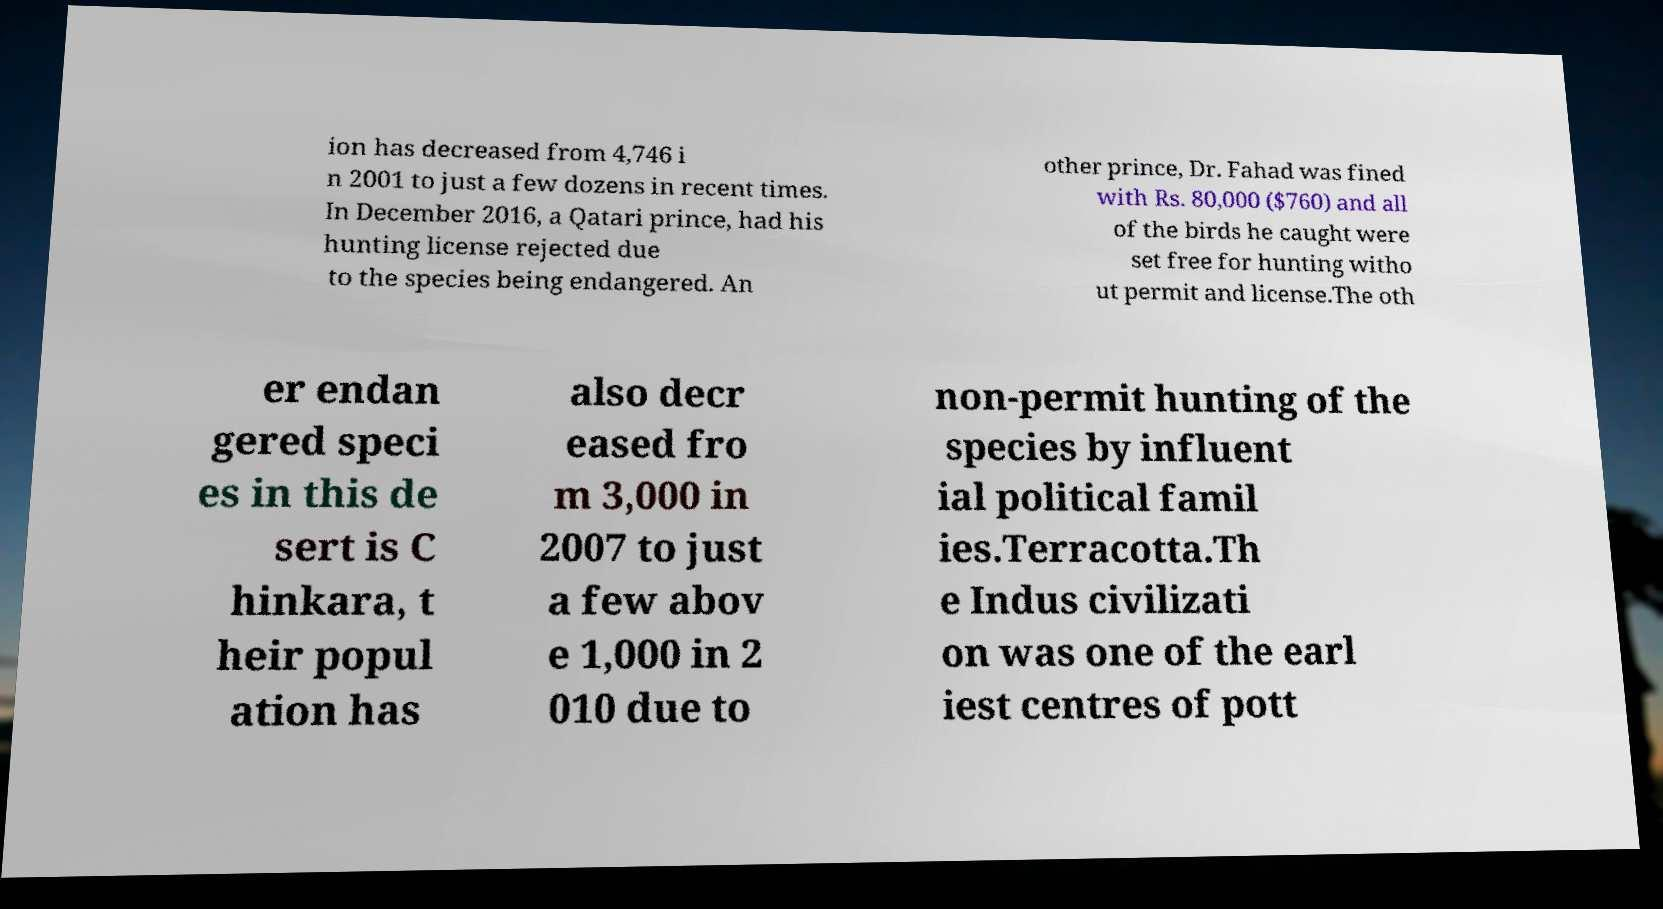I need the written content from this picture converted into text. Can you do that? ion has decreased from 4,746 i n 2001 to just a few dozens in recent times. In December 2016, a Qatari prince, had his hunting license rejected due to the species being endangered. An other prince, Dr. Fahad was fined with Rs. 80,000 ($760) and all of the birds he caught were set free for hunting witho ut permit and license.The oth er endan gered speci es in this de sert is C hinkara, t heir popul ation has also decr eased fro m 3,000 in 2007 to just a few abov e 1,000 in 2 010 due to non-permit hunting of the species by influent ial political famil ies.Terracotta.Th e Indus civilizati on was one of the earl iest centres of pott 